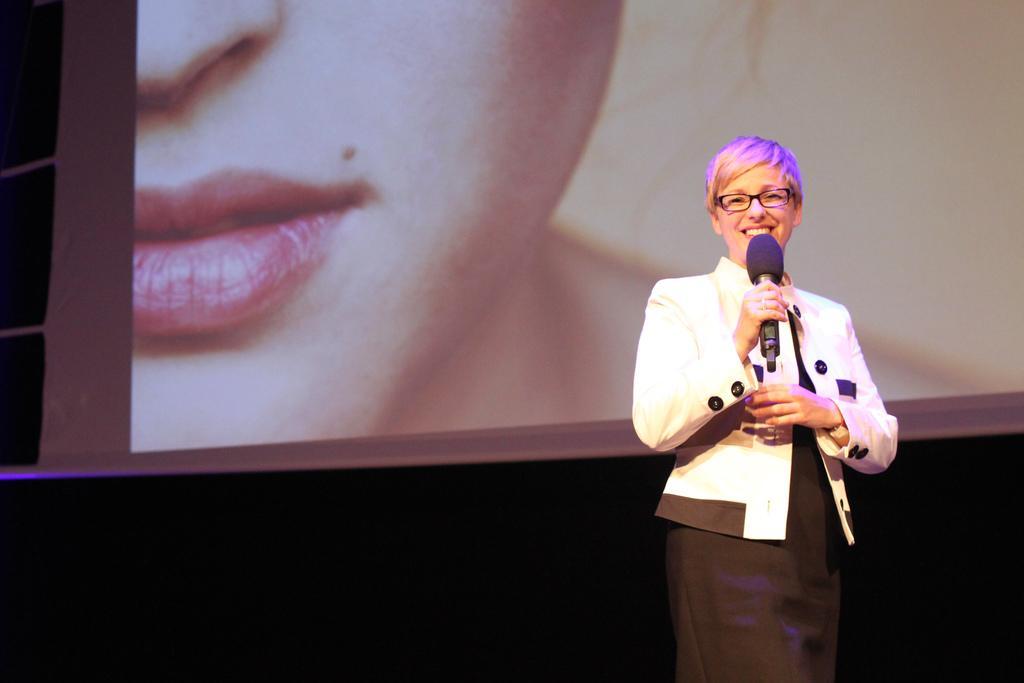Describe this image in one or two sentences. In this image I see a woman who is holding a mic and she is smiling. In the background I see the screen and I see a truncated person's face. 